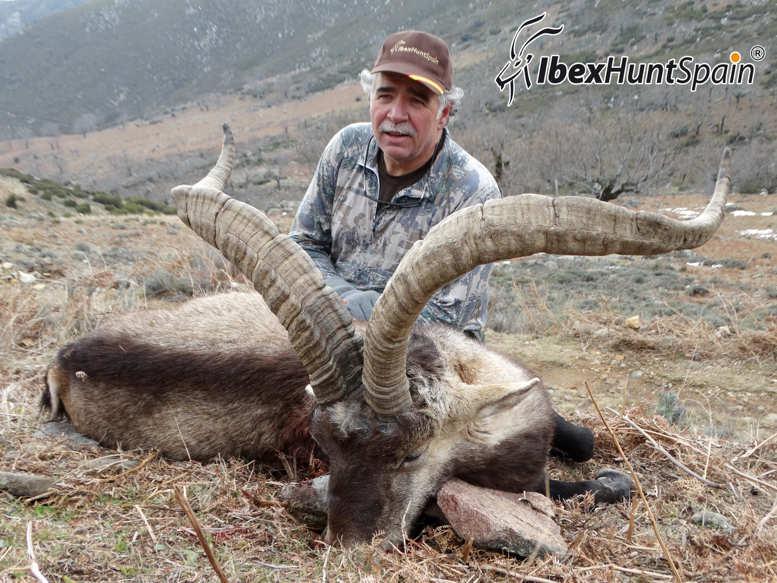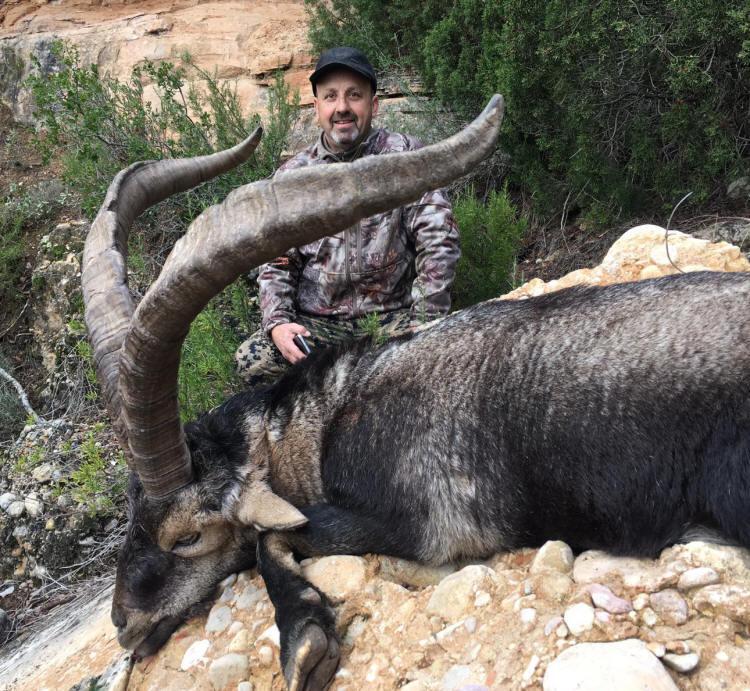The first image is the image on the left, the second image is the image on the right. Examine the images to the left and right. Is the description "The left picture does not have a human in it." accurate? Answer yes or no. No. The first image is the image on the left, the second image is the image on the right. For the images displayed, is the sentence "The left and right image contains a total of  two goats with at least two hunters." factually correct? Answer yes or no. Yes. 